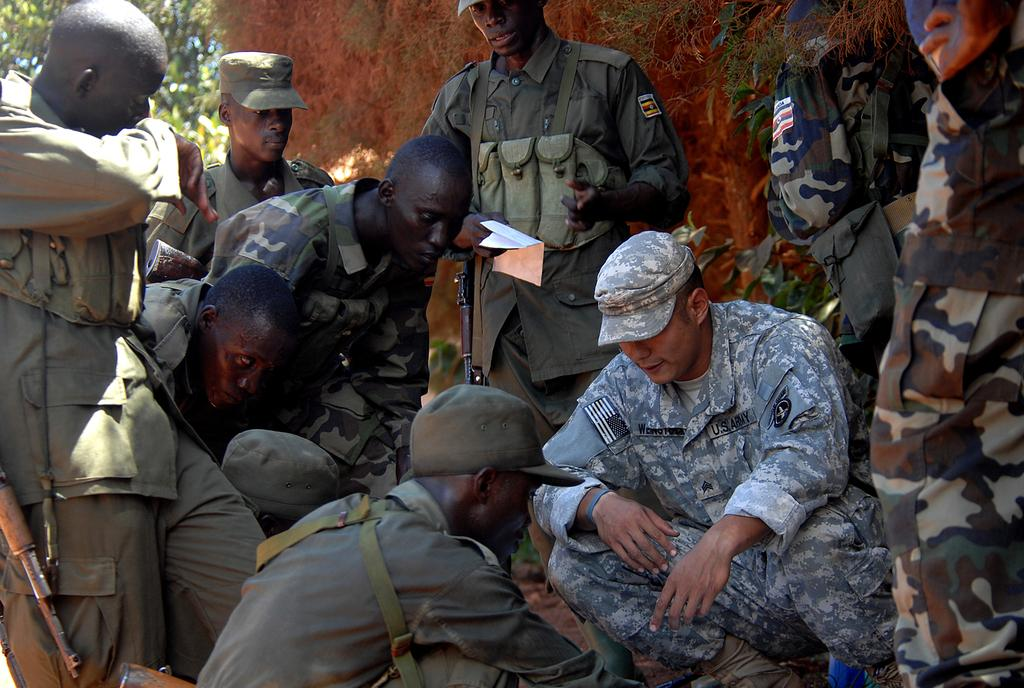What are the people in the image wearing? The people in the image are wearing uniforms. Can you describe the man in the center of the image? The man in the center of the image is standing and holding a paper. What objects can be seen in the image that are typically associated with military or security personnel? There are rifles in the image. What can be seen in the background of the image? There are trees and a wall in the background of the image. How many times does the man sneeze in the image? The man does not sneeze in the image; he is holding a paper. What type of branch is growing from the wall in the image? There is no branch growing from the wall in the image. 